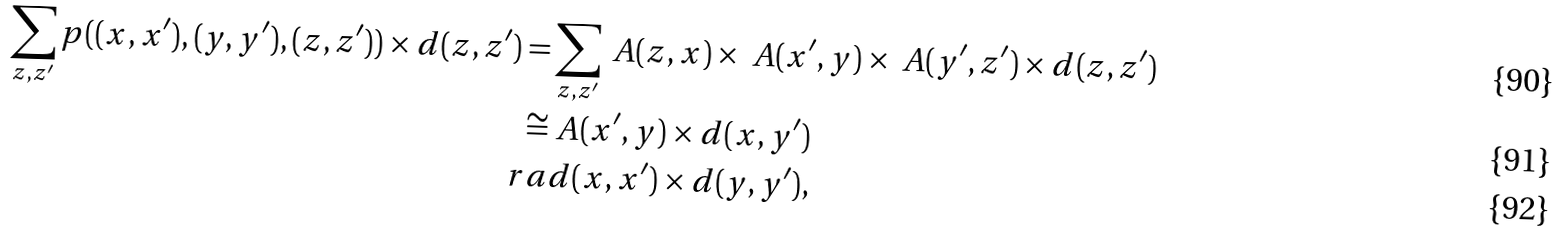Convert formula to latex. <formula><loc_0><loc_0><loc_500><loc_500>\sum _ { z , z ^ { \prime } } p ( ( x , x ^ { \prime } ) , ( y , y ^ { \prime } ) , ( z , z ^ { \prime } ) ) \times d ( z , z ^ { \prime } ) = & \sum _ { z , z ^ { \prime } } \ A ( z , x ) \times \ A ( x ^ { \prime } , y ) \times \ A ( y ^ { \prime } , z ^ { \prime } ) \times d ( z , z ^ { \prime } ) \\ \cong & \ A ( x ^ { \prime } , y ) \times d ( x , y ^ { \prime } ) \\ \ r a & d ( x , x ^ { \prime } ) \times d ( y , y ^ { \prime } ) ,</formula> 